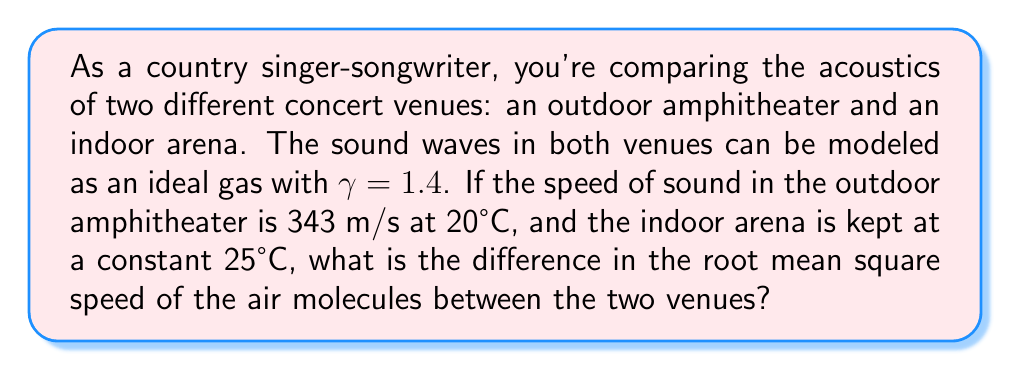What is the answer to this math problem? Let's approach this step-by-step:

1) The speed of sound in an ideal gas is given by:
   $$c = \sqrt{\gamma \frac{RT}{M}}$$
   where $\gamma$ is the heat capacity ratio, $R$ is the gas constant, $T$ is the temperature in Kelvin, and $M$ is the molar mass of the gas.

2) We're given that $\gamma = 1.4$ for air in both venues.

3) For the outdoor amphitheater:
   $T_1 = 20°C = 293.15 K$
   $c_1 = 343 m/s$

4) We can use this to find $\frac{R}{M}$ for air:
   $$343^2 = 1.4 \cdot \frac{R}{M} \cdot 293.15$$
   $$\frac{R}{M} = \frac{343^2}{1.4 \cdot 293.15} = 287.06 \frac{J}{kg \cdot K}$$

5) For the indoor arena:
   $T_2 = 25°C = 298.15 K$
   We can now calculate $c_2$:
   $$c_2 = \sqrt{1.4 \cdot 287.06 \cdot 298.15} = 346.18 m/s$$

6) The root mean square speed of gas molecules is related to the speed of sound:
   $$c = \sqrt{\frac{\gamma}{3}} \cdot v_{rms}$$

7) For the outdoor amphitheater:
   $$v_{rms1} = \frac{343}{\sqrt{\frac{1.4}{3}}} = 501.99 m/s$$

8) For the indoor arena:
   $$v_{rms2} = \frac{346.18}{\sqrt{\frac{1.4}{3}}} = 506.66 m/s$$

9) The difference in root mean square speeds:
   $$\Delta v_{rms} = v_{rms2} - v_{rms1} = 506.66 - 501.99 = 4.67 m/s$$
Answer: 4.67 m/s 